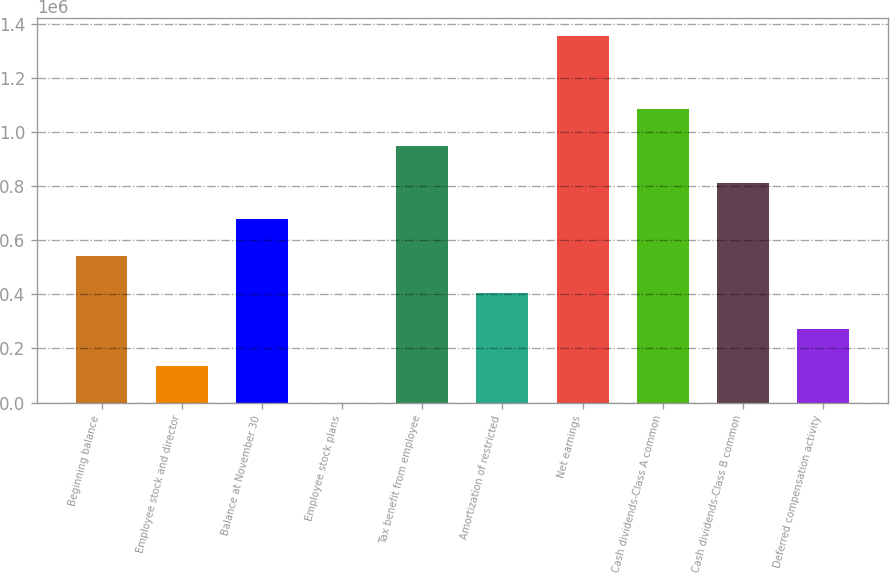<chart> <loc_0><loc_0><loc_500><loc_500><bar_chart><fcel>Beginning balance<fcel>Employee stock and director<fcel>Balance at November 30<fcel>Employee stock plans<fcel>Tax benefit from employee<fcel>Amortization of restricted<fcel>Net earnings<fcel>Cash dividends-Class A common<fcel>Cash dividends-Class B common<fcel>Deferred compensation activity<nl><fcel>542073<fcel>135532<fcel>677586<fcel>18<fcel>948614<fcel>406559<fcel>1.35516e+06<fcel>1.08413e+06<fcel>813100<fcel>271045<nl></chart> 